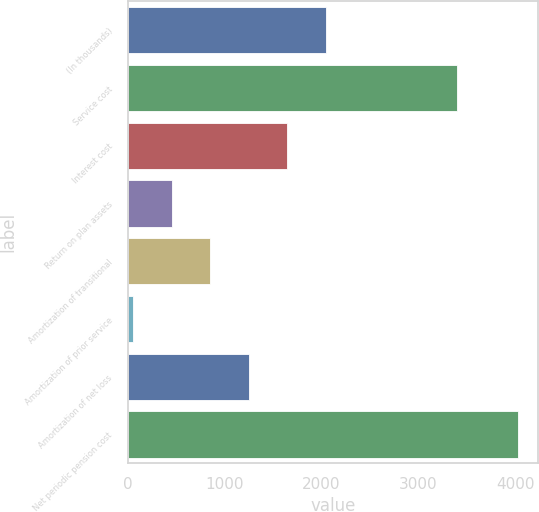<chart> <loc_0><loc_0><loc_500><loc_500><bar_chart><fcel>(In thousands)<fcel>Service cost<fcel>Interest cost<fcel>Return on plan assets<fcel>Amortization of transitional<fcel>Amortization of prior service<fcel>Amortization of net loss<fcel>Net periodic pension cost<nl><fcel>2044.5<fcel>3399<fcel>1647.2<fcel>455.3<fcel>852.6<fcel>58<fcel>1249.9<fcel>4031<nl></chart> 